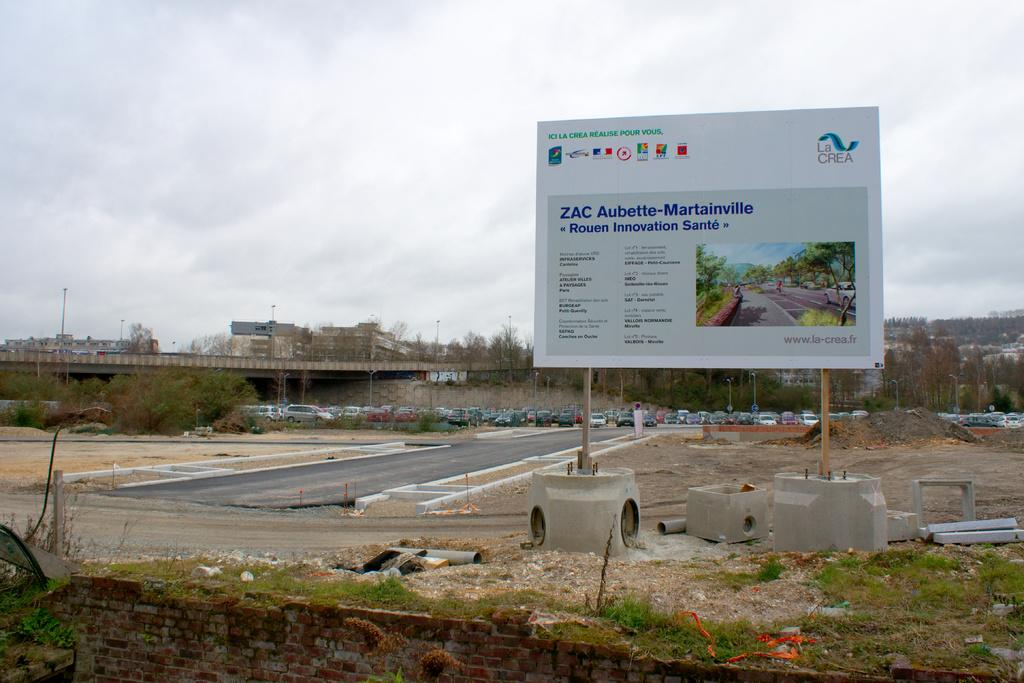<image>
Relay a brief, clear account of the picture shown. A billboard that has "La Crea" written on the top right. 